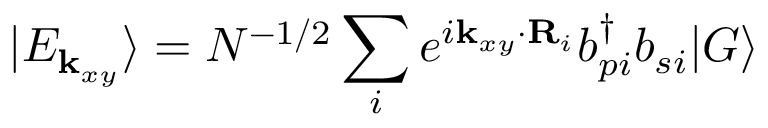<formula> <loc_0><loc_0><loc_500><loc_500>| E _ { { k } _ { x y } } \rangle = N ^ { - 1 / 2 } \sum _ { i } e ^ { i { k } _ { x y } \cdot { R } _ { i } } b _ { p i } ^ { \dagger } b _ { s i } | G \rangle</formula> 